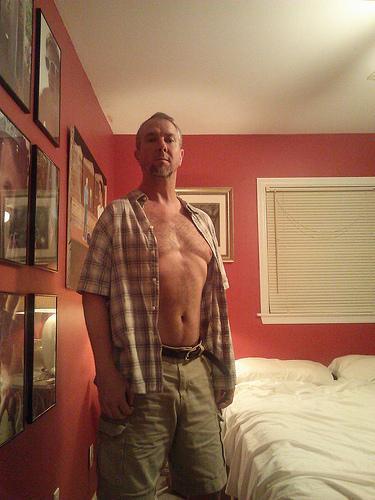How many people are shown?
Give a very brief answer. 1. How many pillows are shown?
Give a very brief answer. 2. 